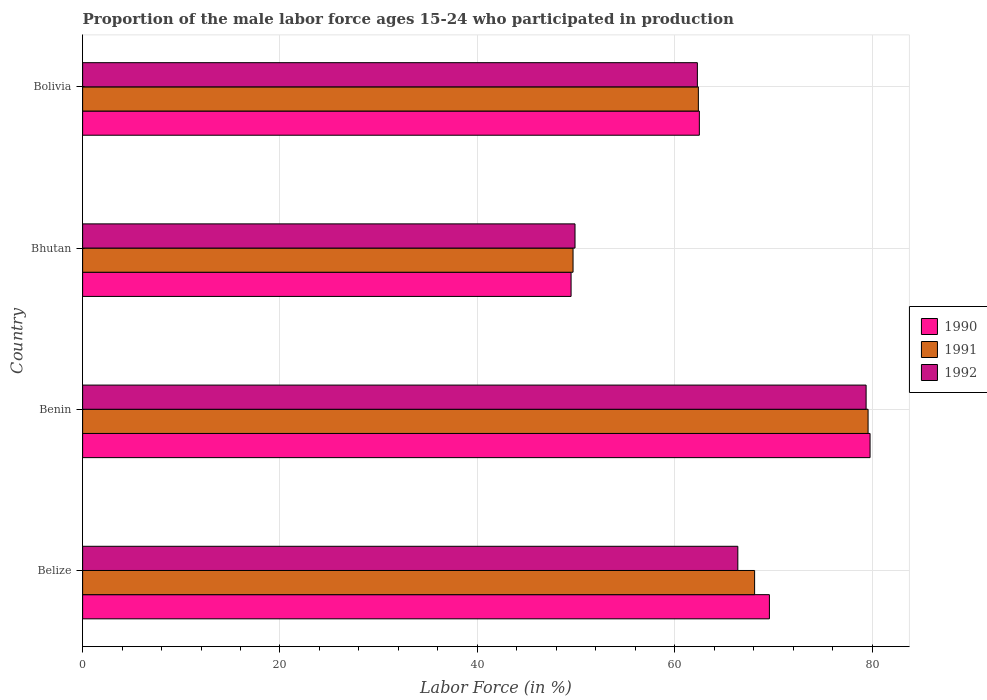How many groups of bars are there?
Offer a terse response. 4. Are the number of bars per tick equal to the number of legend labels?
Give a very brief answer. Yes. How many bars are there on the 4th tick from the bottom?
Offer a terse response. 3. What is the label of the 3rd group of bars from the top?
Offer a terse response. Benin. What is the proportion of the male labor force who participated in production in 1991 in Bhutan?
Your answer should be compact. 49.7. Across all countries, what is the maximum proportion of the male labor force who participated in production in 1990?
Your response must be concise. 79.8. Across all countries, what is the minimum proportion of the male labor force who participated in production in 1992?
Offer a very short reply. 49.9. In which country was the proportion of the male labor force who participated in production in 1990 maximum?
Give a very brief answer. Benin. In which country was the proportion of the male labor force who participated in production in 1990 minimum?
Make the answer very short. Bhutan. What is the total proportion of the male labor force who participated in production in 1992 in the graph?
Your answer should be very brief. 258. What is the difference between the proportion of the male labor force who participated in production in 1990 in Belize and that in Benin?
Your answer should be very brief. -10.2. What is the difference between the proportion of the male labor force who participated in production in 1991 in Bolivia and the proportion of the male labor force who participated in production in 1992 in Benin?
Your response must be concise. -17. What is the average proportion of the male labor force who participated in production in 1990 per country?
Ensure brevity in your answer.  65.35. What is the difference between the proportion of the male labor force who participated in production in 1991 and proportion of the male labor force who participated in production in 1992 in Bhutan?
Give a very brief answer. -0.2. What is the ratio of the proportion of the male labor force who participated in production in 1992 in Benin to that in Bhutan?
Offer a terse response. 1.59. Is the proportion of the male labor force who participated in production in 1990 in Benin less than that in Bolivia?
Provide a short and direct response. No. Is the difference between the proportion of the male labor force who participated in production in 1991 in Benin and Bhutan greater than the difference between the proportion of the male labor force who participated in production in 1992 in Benin and Bhutan?
Your answer should be very brief. Yes. What is the difference between the highest and the second highest proportion of the male labor force who participated in production in 1991?
Make the answer very short. 11.5. What is the difference between the highest and the lowest proportion of the male labor force who participated in production in 1992?
Your response must be concise. 29.5. What does the 2nd bar from the top in Bolivia represents?
Provide a succinct answer. 1991. What does the 2nd bar from the bottom in Bolivia represents?
Give a very brief answer. 1991. Is it the case that in every country, the sum of the proportion of the male labor force who participated in production in 1990 and proportion of the male labor force who participated in production in 1991 is greater than the proportion of the male labor force who participated in production in 1992?
Ensure brevity in your answer.  Yes. Does the graph contain any zero values?
Provide a succinct answer. No. Where does the legend appear in the graph?
Ensure brevity in your answer.  Center right. How are the legend labels stacked?
Offer a terse response. Vertical. What is the title of the graph?
Ensure brevity in your answer.  Proportion of the male labor force ages 15-24 who participated in production. Does "1995" appear as one of the legend labels in the graph?
Your answer should be compact. No. What is the label or title of the Y-axis?
Give a very brief answer. Country. What is the Labor Force (in %) in 1990 in Belize?
Your answer should be compact. 69.6. What is the Labor Force (in %) of 1991 in Belize?
Your answer should be compact. 68.1. What is the Labor Force (in %) of 1992 in Belize?
Keep it short and to the point. 66.4. What is the Labor Force (in %) of 1990 in Benin?
Your answer should be very brief. 79.8. What is the Labor Force (in %) of 1991 in Benin?
Your response must be concise. 79.6. What is the Labor Force (in %) of 1992 in Benin?
Ensure brevity in your answer.  79.4. What is the Labor Force (in %) of 1990 in Bhutan?
Your answer should be very brief. 49.5. What is the Labor Force (in %) of 1991 in Bhutan?
Provide a short and direct response. 49.7. What is the Labor Force (in %) of 1992 in Bhutan?
Offer a very short reply. 49.9. What is the Labor Force (in %) in 1990 in Bolivia?
Keep it short and to the point. 62.5. What is the Labor Force (in %) of 1991 in Bolivia?
Keep it short and to the point. 62.4. What is the Labor Force (in %) of 1992 in Bolivia?
Your answer should be very brief. 62.3. Across all countries, what is the maximum Labor Force (in %) in 1990?
Offer a terse response. 79.8. Across all countries, what is the maximum Labor Force (in %) of 1991?
Your answer should be very brief. 79.6. Across all countries, what is the maximum Labor Force (in %) of 1992?
Provide a short and direct response. 79.4. Across all countries, what is the minimum Labor Force (in %) in 1990?
Offer a terse response. 49.5. Across all countries, what is the minimum Labor Force (in %) in 1991?
Your response must be concise. 49.7. Across all countries, what is the minimum Labor Force (in %) in 1992?
Ensure brevity in your answer.  49.9. What is the total Labor Force (in %) in 1990 in the graph?
Your response must be concise. 261.4. What is the total Labor Force (in %) in 1991 in the graph?
Your response must be concise. 259.8. What is the total Labor Force (in %) of 1992 in the graph?
Provide a short and direct response. 258. What is the difference between the Labor Force (in %) of 1991 in Belize and that in Benin?
Give a very brief answer. -11.5. What is the difference between the Labor Force (in %) in 1990 in Belize and that in Bhutan?
Provide a succinct answer. 20.1. What is the difference between the Labor Force (in %) of 1991 in Belize and that in Bhutan?
Ensure brevity in your answer.  18.4. What is the difference between the Labor Force (in %) in 1990 in Benin and that in Bhutan?
Offer a very short reply. 30.3. What is the difference between the Labor Force (in %) of 1991 in Benin and that in Bhutan?
Your answer should be very brief. 29.9. What is the difference between the Labor Force (in %) of 1992 in Benin and that in Bhutan?
Keep it short and to the point. 29.5. What is the difference between the Labor Force (in %) in 1992 in Bhutan and that in Bolivia?
Offer a very short reply. -12.4. What is the difference between the Labor Force (in %) of 1990 in Belize and the Labor Force (in %) of 1992 in Benin?
Your answer should be compact. -9.8. What is the difference between the Labor Force (in %) of 1990 in Belize and the Labor Force (in %) of 1991 in Bhutan?
Provide a succinct answer. 19.9. What is the difference between the Labor Force (in %) of 1990 in Benin and the Labor Force (in %) of 1991 in Bhutan?
Offer a terse response. 30.1. What is the difference between the Labor Force (in %) in 1990 in Benin and the Labor Force (in %) in 1992 in Bhutan?
Make the answer very short. 29.9. What is the difference between the Labor Force (in %) in 1991 in Benin and the Labor Force (in %) in 1992 in Bhutan?
Your response must be concise. 29.7. What is the difference between the Labor Force (in %) in 1990 in Benin and the Labor Force (in %) in 1991 in Bolivia?
Keep it short and to the point. 17.4. What is the difference between the Labor Force (in %) in 1991 in Bhutan and the Labor Force (in %) in 1992 in Bolivia?
Give a very brief answer. -12.6. What is the average Labor Force (in %) of 1990 per country?
Ensure brevity in your answer.  65.35. What is the average Labor Force (in %) of 1991 per country?
Your answer should be compact. 64.95. What is the average Labor Force (in %) of 1992 per country?
Keep it short and to the point. 64.5. What is the difference between the Labor Force (in %) of 1990 and Labor Force (in %) of 1991 in Belize?
Your answer should be very brief. 1.5. What is the difference between the Labor Force (in %) in 1991 and Labor Force (in %) in 1992 in Benin?
Offer a very short reply. 0.2. What is the difference between the Labor Force (in %) in 1990 and Labor Force (in %) in 1991 in Bhutan?
Make the answer very short. -0.2. What is the difference between the Labor Force (in %) of 1990 and Labor Force (in %) of 1992 in Bhutan?
Your answer should be very brief. -0.4. What is the difference between the Labor Force (in %) in 1991 and Labor Force (in %) in 1992 in Bhutan?
Give a very brief answer. -0.2. What is the difference between the Labor Force (in %) of 1990 and Labor Force (in %) of 1992 in Bolivia?
Offer a terse response. 0.2. What is the ratio of the Labor Force (in %) in 1990 in Belize to that in Benin?
Your response must be concise. 0.87. What is the ratio of the Labor Force (in %) of 1991 in Belize to that in Benin?
Give a very brief answer. 0.86. What is the ratio of the Labor Force (in %) in 1992 in Belize to that in Benin?
Your response must be concise. 0.84. What is the ratio of the Labor Force (in %) in 1990 in Belize to that in Bhutan?
Provide a short and direct response. 1.41. What is the ratio of the Labor Force (in %) in 1991 in Belize to that in Bhutan?
Your answer should be compact. 1.37. What is the ratio of the Labor Force (in %) of 1992 in Belize to that in Bhutan?
Keep it short and to the point. 1.33. What is the ratio of the Labor Force (in %) in 1990 in Belize to that in Bolivia?
Offer a terse response. 1.11. What is the ratio of the Labor Force (in %) of 1991 in Belize to that in Bolivia?
Keep it short and to the point. 1.09. What is the ratio of the Labor Force (in %) in 1992 in Belize to that in Bolivia?
Provide a short and direct response. 1.07. What is the ratio of the Labor Force (in %) of 1990 in Benin to that in Bhutan?
Give a very brief answer. 1.61. What is the ratio of the Labor Force (in %) in 1991 in Benin to that in Bhutan?
Your response must be concise. 1.6. What is the ratio of the Labor Force (in %) in 1992 in Benin to that in Bhutan?
Ensure brevity in your answer.  1.59. What is the ratio of the Labor Force (in %) in 1990 in Benin to that in Bolivia?
Your response must be concise. 1.28. What is the ratio of the Labor Force (in %) in 1991 in Benin to that in Bolivia?
Give a very brief answer. 1.28. What is the ratio of the Labor Force (in %) in 1992 in Benin to that in Bolivia?
Offer a very short reply. 1.27. What is the ratio of the Labor Force (in %) of 1990 in Bhutan to that in Bolivia?
Your answer should be very brief. 0.79. What is the ratio of the Labor Force (in %) in 1991 in Bhutan to that in Bolivia?
Make the answer very short. 0.8. What is the ratio of the Labor Force (in %) in 1992 in Bhutan to that in Bolivia?
Ensure brevity in your answer.  0.8. What is the difference between the highest and the second highest Labor Force (in %) of 1990?
Your response must be concise. 10.2. What is the difference between the highest and the lowest Labor Force (in %) in 1990?
Your response must be concise. 30.3. What is the difference between the highest and the lowest Labor Force (in %) in 1991?
Make the answer very short. 29.9. What is the difference between the highest and the lowest Labor Force (in %) in 1992?
Keep it short and to the point. 29.5. 